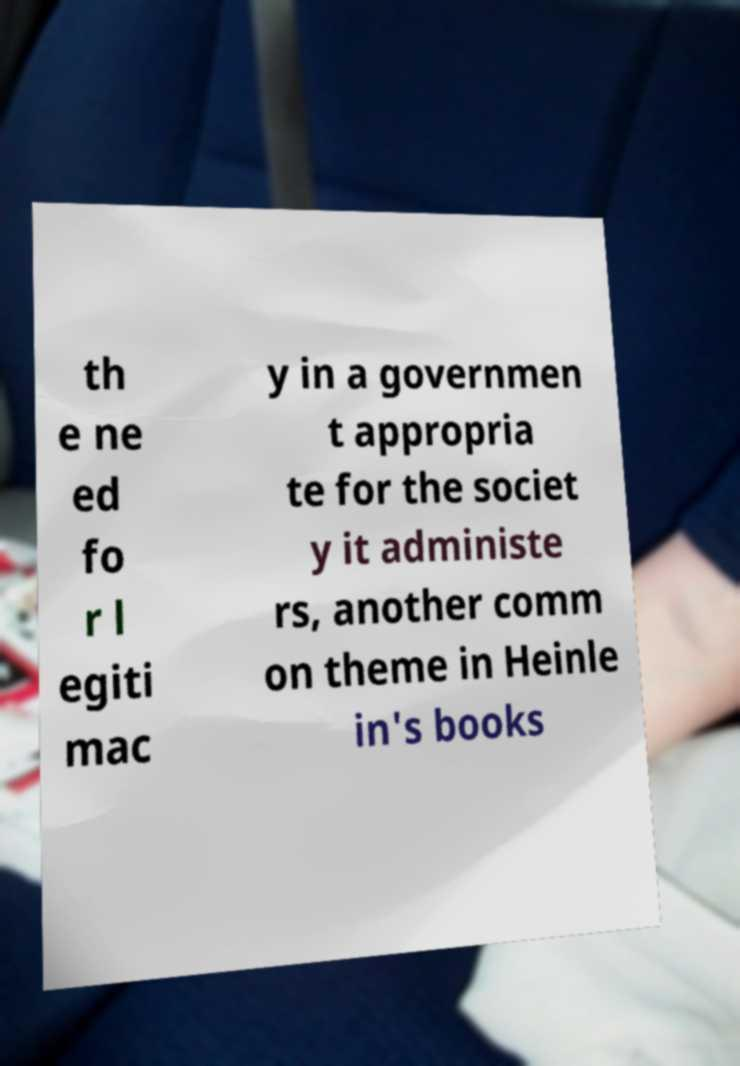I need the written content from this picture converted into text. Can you do that? th e ne ed fo r l egiti mac y in a governmen t appropria te for the societ y it administe rs, another comm on theme in Heinle in's books 